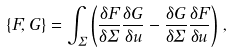<formula> <loc_0><loc_0><loc_500><loc_500>\{ F , G \} = \int _ { \Sigma } \left ( \frac { \delta F } { \delta \Sigma } \frac { \delta G } { \delta u } - \frac { \delta G } { \delta \Sigma } \frac { \delta F } { \delta u } \right ) \, ,</formula> 